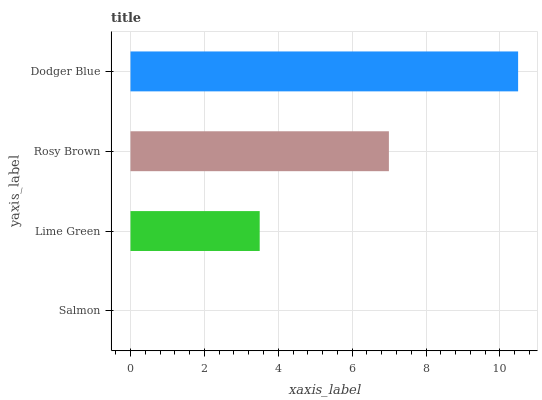Is Salmon the minimum?
Answer yes or no. Yes. Is Dodger Blue the maximum?
Answer yes or no. Yes. Is Lime Green the minimum?
Answer yes or no. No. Is Lime Green the maximum?
Answer yes or no. No. Is Lime Green greater than Salmon?
Answer yes or no. Yes. Is Salmon less than Lime Green?
Answer yes or no. Yes. Is Salmon greater than Lime Green?
Answer yes or no. No. Is Lime Green less than Salmon?
Answer yes or no. No. Is Rosy Brown the high median?
Answer yes or no. Yes. Is Lime Green the low median?
Answer yes or no. Yes. Is Lime Green the high median?
Answer yes or no. No. Is Rosy Brown the low median?
Answer yes or no. No. 